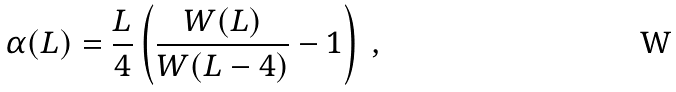Convert formula to latex. <formula><loc_0><loc_0><loc_500><loc_500>\alpha ( L ) = \frac { L } { 4 } \left ( \frac { W ( L ) } { W ( L - 4 ) } - 1 \right ) \ ,</formula> 